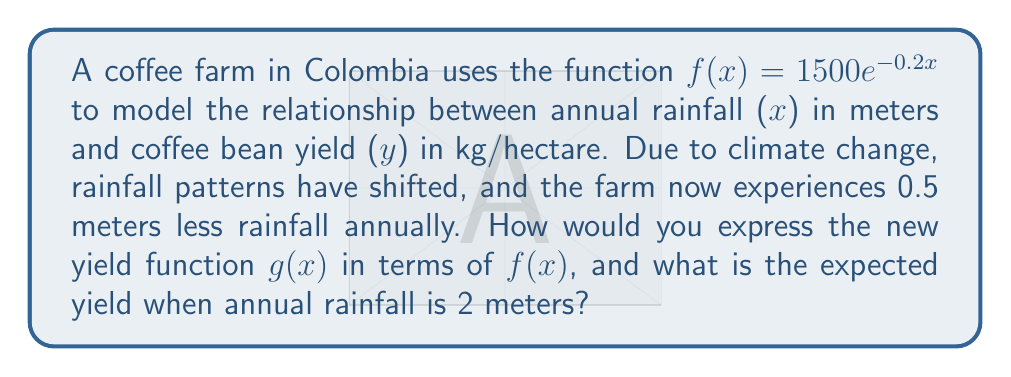Solve this math problem. 1) The original function is $f(x) = 1500e^{-0.2x}$, where x is the annual rainfall in meters.

2) Due to climate change, there is 0.5 meters less rainfall annually. This means we need to shift the function 0.5 units to the right.

3) To shift a function h units to the right, we replace x with (x - h). In this case, h = 0.5.

4) Therefore, the new function g(x) can be expressed as:
   $g(x) = f(x - 0.5)$

5) To find the yield when annual rainfall is 2 meters, we need to calculate g(2):
   $g(2) = f(2 - 0.5) = f(1.5)$

6) Now we can calculate f(1.5):
   $f(1.5) = 1500e^{-0.2(1.5)}$

7) Simplifying:
   $f(1.5) = 1500e^{-0.3}$
   $f(1.5) = 1500 * (e^{-0.3})$
   $f(1.5) = 1500 * 0.7408$
   $f(1.5) \approx 1111.2$

Therefore, the expected yield when annual rainfall is 2 meters is approximately 1111.2 kg/hectare.
Answer: $g(x) = f(x - 0.5)$; 1111.2 kg/hectare 